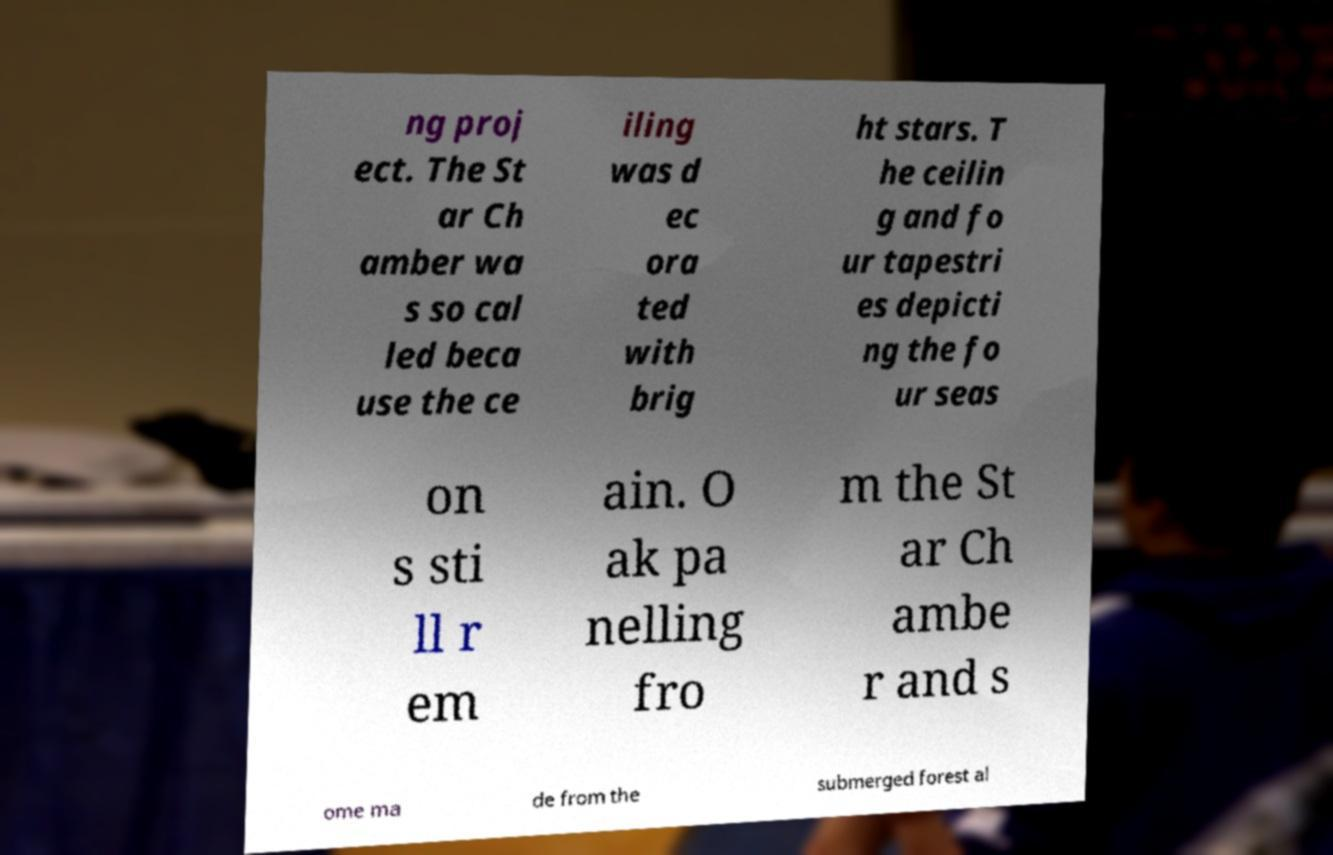Please identify and transcribe the text found in this image. ng proj ect. The St ar Ch amber wa s so cal led beca use the ce iling was d ec ora ted with brig ht stars. T he ceilin g and fo ur tapestri es depicti ng the fo ur seas on s sti ll r em ain. O ak pa nelling fro m the St ar Ch ambe r and s ome ma de from the submerged forest al 